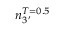<formula> <loc_0><loc_0><loc_500><loc_500>n _ { 3 ^ { \prime } } ^ { T = 0 . 5 }</formula> 